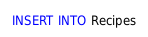Convert code to text. <code><loc_0><loc_0><loc_500><loc_500><_SQL_>INSERT INTO Recipes</code> 